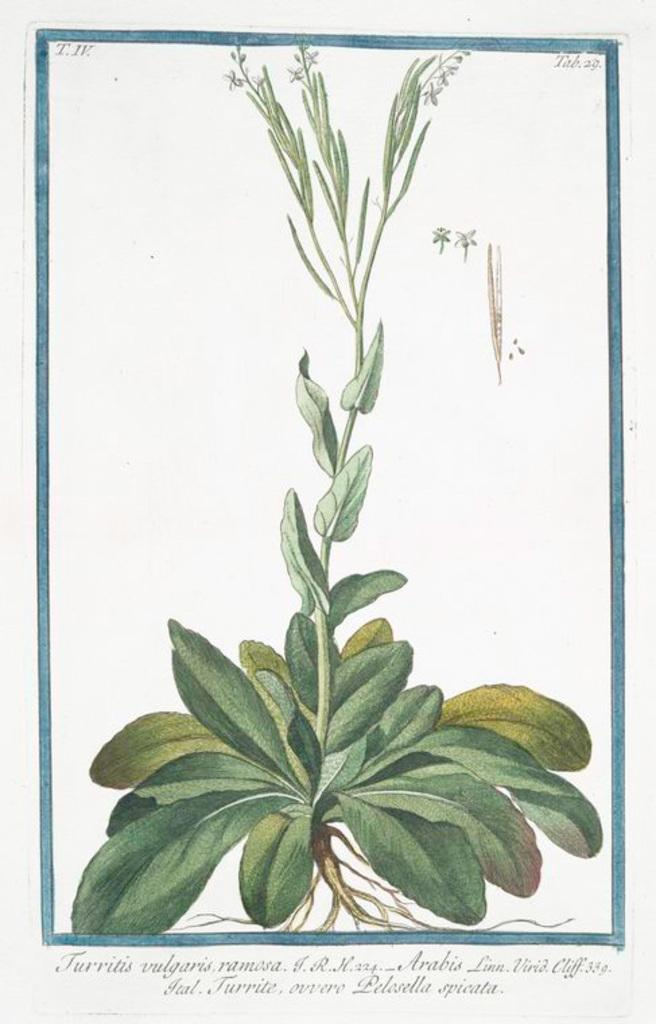What is featured in the image? There is a poster in the image. What can be found on the poster? The poster contains text and a plant. How many cherries are on the plant depicted on the poster? There are no cherries present on the plant depicted on the poster. What advice does the poster's text give to the viewer's aunt? There is no mention of an aunt in the image or the text on the poster. 